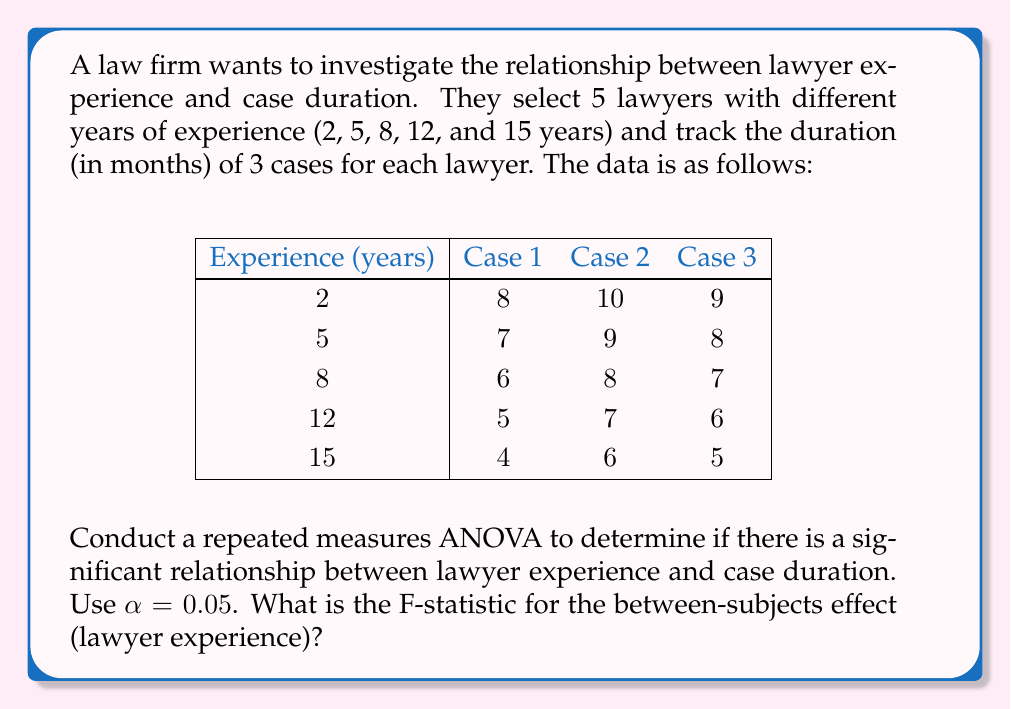Show me your answer to this math problem. To conduct a repeated measures ANOVA, we need to follow these steps:

1. Calculate the total sum of squares (SST)
2. Calculate the between-subjects sum of squares (SSB)
3. Calculate the within-subjects sum of squares (SSW)
4. Calculate the error sum of squares (SSE)
5. Calculate the degrees of freedom
6. Calculate the mean squares
7. Calculate the F-statistic

Step 1: Calculate SST
First, we need to find the grand mean:
$$\bar{X} = \frac{8+10+9+7+9+8+6+8+7+5+7+6+4+6+5}{15} = 7$$

Now, we can calculate SST:
$$SST = \sum_{i=1}^{5}\sum_{j=1}^{3}(X_{ij} - \bar{X})^2 = 56$$

Step 2: Calculate SSB
We need to find the mean for each experience level:
$$\bar{X}_1 = 9, \bar{X}_2 = 8, \bar{X}_3 = 7, \bar{X}_4 = 6, \bar{X}_5 = 5$$

Now, we can calculate SSB:
$$SSB = 3\sum_{i=1}^{5}(\bar{X}_i - \bar{X})^2 = 3(2^2 + 1^2 + 0^2 + (-1)^2 + (-2)^2) = 30$$

Step 3: Calculate SSW
$$SSW = SST - SSB = 56 - 30 = 26$$

Step 4: Calculate SSE
We need to find the mean for each case:
$$\bar{X}_{Case1} = 6, \bar{X}_{Case2} = 8, \bar{X}_{Case3} = 7$$

Now, we can calculate SSE:
$$SSE = SSW - 5\sum_{j=1}^{3}(\bar{X}_j - \bar{X})^2 = 26 - 5((-1)^2 + 1^2 + 0^2) = 16$$

Step 5: Calculate degrees of freedom
$$df_{between} = 5 - 1 = 4$$
$$df_{within} = 5(3 - 1) = 10$$
$$df_{error} = (5 - 1)(3 - 1) = 8$$

Step 6: Calculate mean squares
$$MS_{between} = \frac{SSB}{df_{between}} = \frac{30}{4} = 7.5$$
$$MS_{error} = \frac{SSE}{df_{error}} = \frac{16}{8} = 2$$

Step 7: Calculate F-statistic
$$F = \frac{MS_{between}}{MS_{error}} = \frac{7.5}{2} = 3.75$$

The F-statistic for the between-subjects effect (lawyer experience) is 3.75.
Answer: The F-statistic for the between-subjects effect (lawyer experience) is 3.75. 